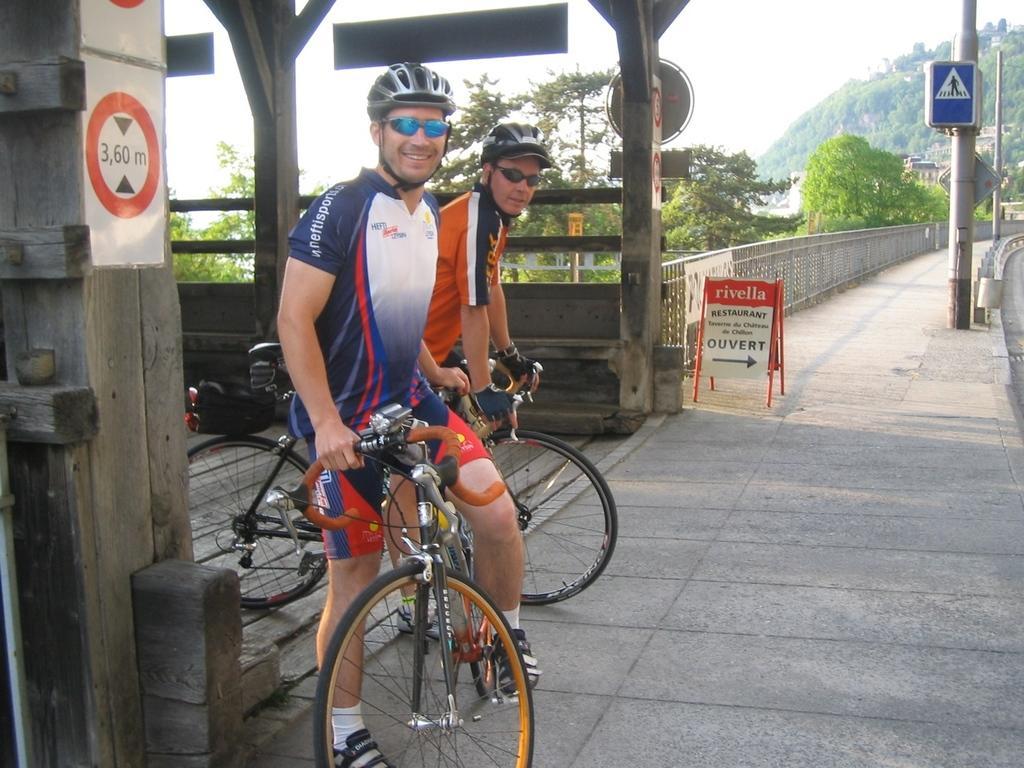Can you describe this image briefly? The picture is taken outside a road. In the middle two persons are riding bicycle. They are wearing helmet and glasses. There is fence around the road. There are poles on the road. In the background there are trees and hill. 